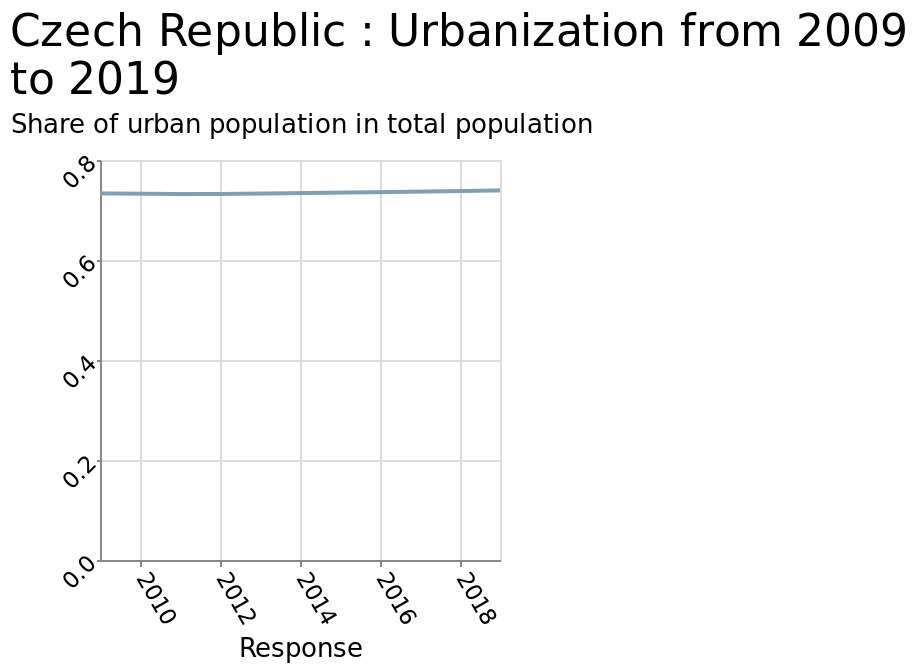<image>
What is the maximum value on the y-axis?  The maximum value on the y-axis is 0.8. please enumerates aspects of the construction of the chart This is a line diagram called Czech Republic : Urbanization from 2009 to 2019. The x-axis plots Response using linear scale of range 2010 to 2018 while the y-axis plots Share of urban population in total population along linear scale with a minimum of 0.0 and a maximum of 0.8. Has the urbanisation rate in the Czech Republic changed between 2009 and 2019? No, the urbanisation rate in the Czech Republic has remained constant between 2009 and 2019. 